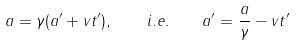<formula> <loc_0><loc_0><loc_500><loc_500>a = \gamma ( a ^ { \prime } + { v } t ^ { \prime } ) , \quad i . e . \quad a ^ { \prime } = \frac { a } { \gamma } - { v } t ^ { \prime }</formula> 